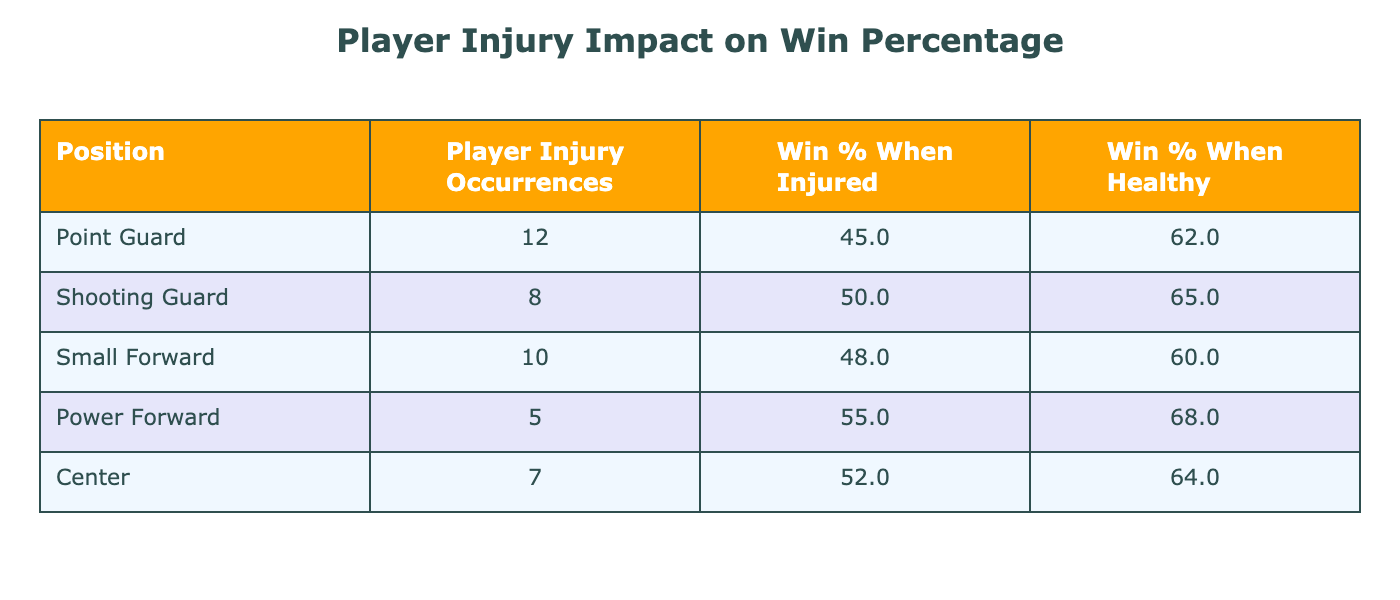What is the win percentage for Small Forwards when they are injured? According to the table, the column for "Win Percentage When Injured" under Small Forward shows a value of 48%.
Answer: 48% Which position has the highest win percentage when healthy? Looking at the "Win Percentage When Healthy" column, the Power Forward position has the highest value of 68%.
Answer: Power Forward How many player injury occurrences are recorded for Point Guards? The table presents a count of 12 under "Player Injury Occurrences" for the Point Guard position.
Answer: 12 What is the difference in win percentage between Shooting Guards when they are healthy versus when they are injured? For Shooting Guards, the win percentage is 65% when healthy and 50% when injured. The difference is 65% - 50% = 15%.
Answer: 15% Is it true that Centers have a better win percentage when injured compared to their win percentage when healthy? The win percentage for Centers is 52% when injured and 64% when healthy, so this statement is false.
Answer: No Which position experiences fewer player injury occurrences, Power Forward or Center? The table shows that Power Forwards have 5 injury occurrences and Centers have 7. Since 5 is less than 7, Power Forwards experience fewer injuries.
Answer: Power Forward What is the average win percentage when injured across all positions? To find the average, sum the win percentages when injured: (45 + 50 + 48 + 55 + 52) = 250. There are 5 positions, so the average is 250/5 = 50%.
Answer: 50% Which position has the largest gap between their win percentage when injured and when healthy? For each position, calculate the difference: Point Guards (17%), Shooting Guards (15%), Small Forwards (12%), Power Forwards (13%), and Centers (12%). The largest gap is for Point Guards, which is 17%.
Answer: Point Guard Are there more player injury occurrences for Guards combined than for Forwards combined? Calculate the occurrences: Point Guards (12) + Shooting Guards (8) = 20 for Guards; Small Forwards (10) + Power Forwards (5) = 15 for Forwards. Since 20 is greater than 15, this statement is true.
Answer: Yes 